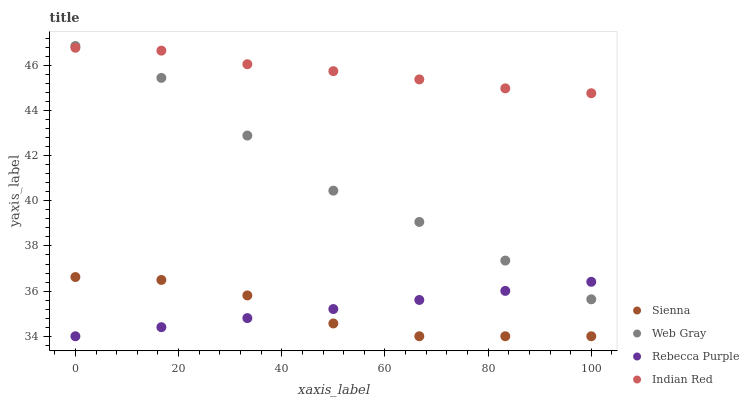Does Sienna have the minimum area under the curve?
Answer yes or no. Yes. Does Indian Red have the maximum area under the curve?
Answer yes or no. Yes. Does Web Gray have the minimum area under the curve?
Answer yes or no. No. Does Web Gray have the maximum area under the curve?
Answer yes or no. No. Is Rebecca Purple the smoothest?
Answer yes or no. Yes. Is Web Gray the roughest?
Answer yes or no. Yes. Is Web Gray the smoothest?
Answer yes or no. No. Is Rebecca Purple the roughest?
Answer yes or no. No. Does Sienna have the lowest value?
Answer yes or no. Yes. Does Web Gray have the lowest value?
Answer yes or no. No. Does Web Gray have the highest value?
Answer yes or no. Yes. Does Rebecca Purple have the highest value?
Answer yes or no. No. Is Rebecca Purple less than Indian Red?
Answer yes or no. Yes. Is Indian Red greater than Sienna?
Answer yes or no. Yes. Does Indian Red intersect Web Gray?
Answer yes or no. Yes. Is Indian Red less than Web Gray?
Answer yes or no. No. Is Indian Red greater than Web Gray?
Answer yes or no. No. Does Rebecca Purple intersect Indian Red?
Answer yes or no. No. 